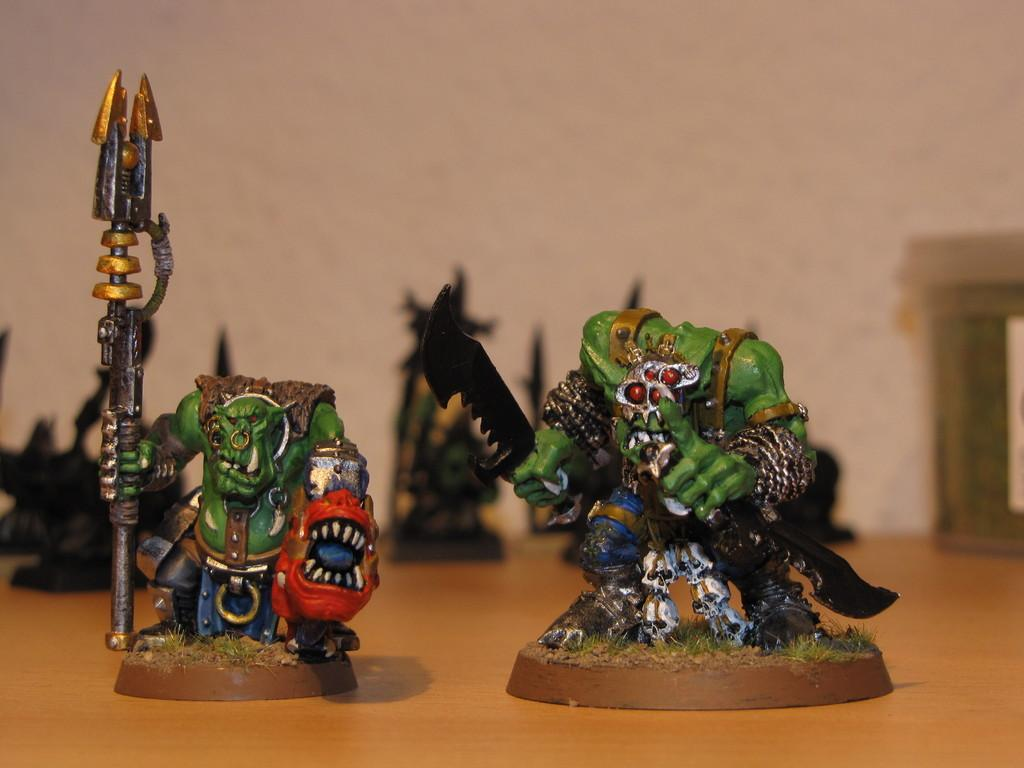What is the color of the surface in the image? The surface in the image is brown. What can be found on the surface? There are toys on the surface. What colors are the toys? The toys are green, brown, black, and orange in color. Can you describe the background of the image? The background of the image is blurry. How does the lock on the toys affect their movement in the image? There is no lock present on the toys in the image, so it does not affect their movement. 